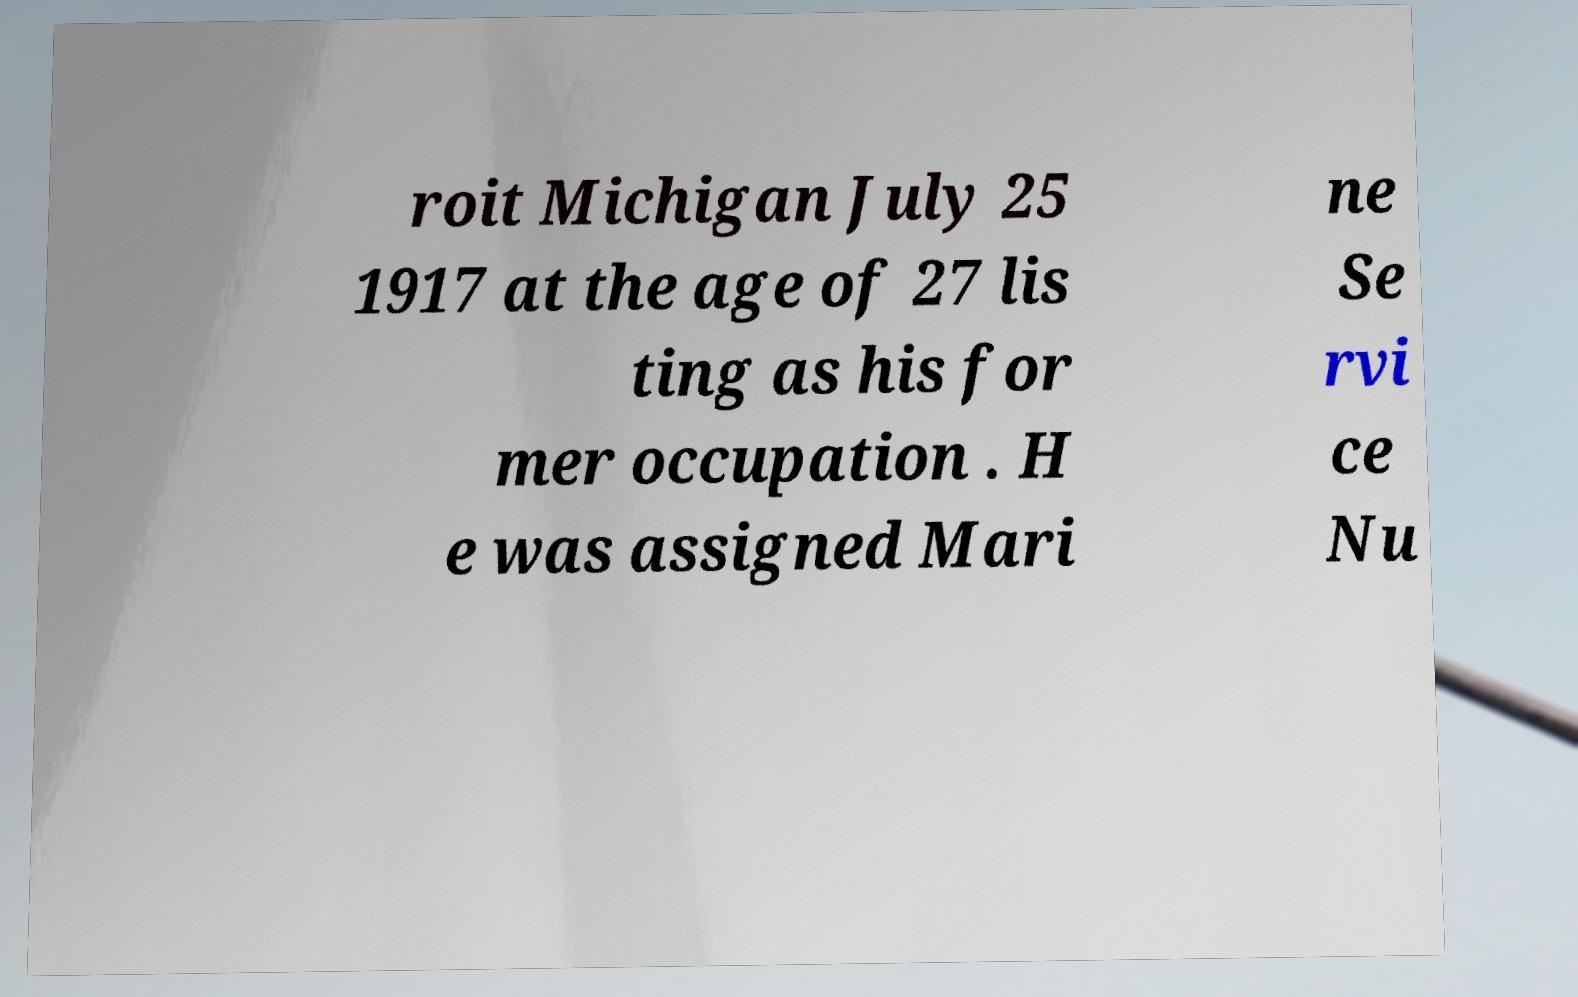For documentation purposes, I need the text within this image transcribed. Could you provide that? roit Michigan July 25 1917 at the age of 27 lis ting as his for mer occupation . H e was assigned Mari ne Se rvi ce Nu 